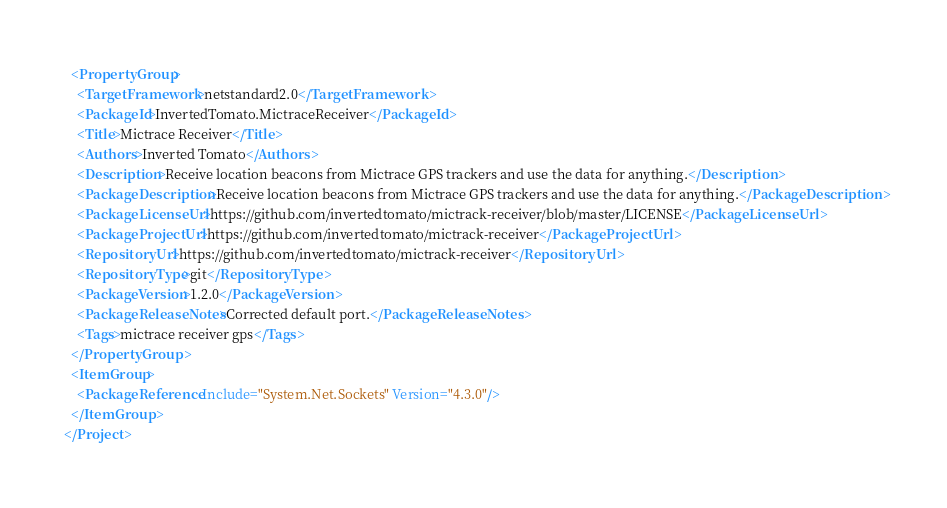<code> <loc_0><loc_0><loc_500><loc_500><_XML_>  <PropertyGroup>
    <TargetFramework>netstandard2.0</TargetFramework>
    <PackageId>InvertedTomato.MictraceReceiver</PackageId>
    <Title>Mictrace Receiver</Title>
    <Authors>Inverted Tomato</Authors>
    <Description>Receive location beacons from Mictrace GPS trackers and use the data for anything.</Description>
    <PackageDescription>Receive location beacons from Mictrace GPS trackers and use the data for anything.</PackageDescription>
    <PackageLicenseUrl>https://github.com/invertedtomato/mictrack-receiver/blob/master/LICENSE</PackageLicenseUrl>
    <PackageProjectUrl>https://github.com/invertedtomato/mictrack-receiver</PackageProjectUrl>
    <RepositoryUrl>https://github.com/invertedtomato/mictrack-receiver</RepositoryUrl>
    <RepositoryType>git</RepositoryType>
    <PackageVersion>1.2.0</PackageVersion>
    <PackageReleaseNotes>Corrected default port.</PackageReleaseNotes>
    <Tags>mictrace receiver gps</Tags>
  </PropertyGroup>
  <ItemGroup>
    <PackageReference Include="System.Net.Sockets" Version="4.3.0"/>
  </ItemGroup>
</Project></code> 